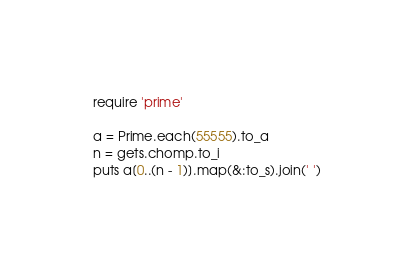<code> <loc_0><loc_0><loc_500><loc_500><_Ruby_>require 'prime'

a = Prime.each(55555).to_a
n = gets.chomp.to_i
puts a[0..(n - 1)].map(&:to_s).join(' ')</code> 